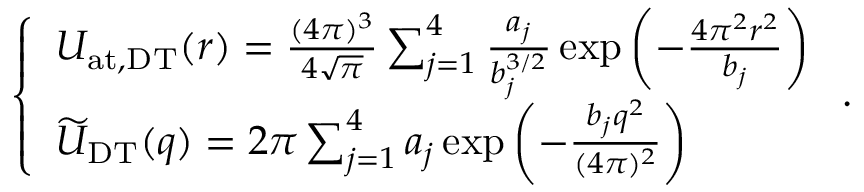Convert formula to latex. <formula><loc_0><loc_0><loc_500><loc_500>\begin{array} { r } { \left \{ \begin{array} { l l } { U _ { a t , D T } ( r ) = { \frac { ( 4 \pi ) ^ { 3 } } { 4 \sqrt { \pi } } } \sum _ { j = 1 } ^ { 4 } { \frac { a _ { j } } { b _ { j } ^ { 3 / 2 } } } \exp \left ( - { \frac { 4 \pi ^ { 2 } r ^ { 2 } } { b _ { j } } } \right ) } \\ { \widetilde { U } _ { D T } ( q ) = 2 \pi \sum _ { j = 1 } ^ { 4 } a _ { j } \exp \left ( - { \frac { b _ { j } q ^ { 2 } } { ( 4 \pi ) ^ { 2 } } } \right ) } \end{array} . } \end{array}</formula> 